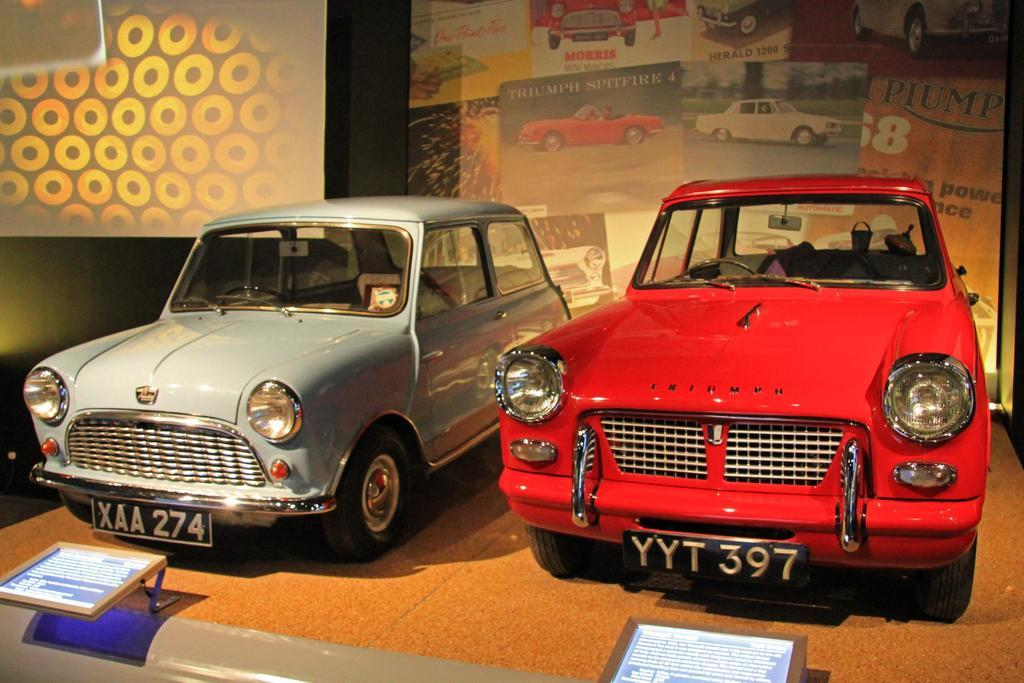What objects are on the floor in the image? There are two cars on the floor in the image. What can be seen in the background of the image? There are screens with different cars and text in the background of the image. What additional information is provided at the bottom of the image? There are two informational boards at the bottom of the image. How many boats are visible in the image? There are no boats present in the image. What day of the week is it in the image? The day of the week is not mentioned or depicted in the image. 